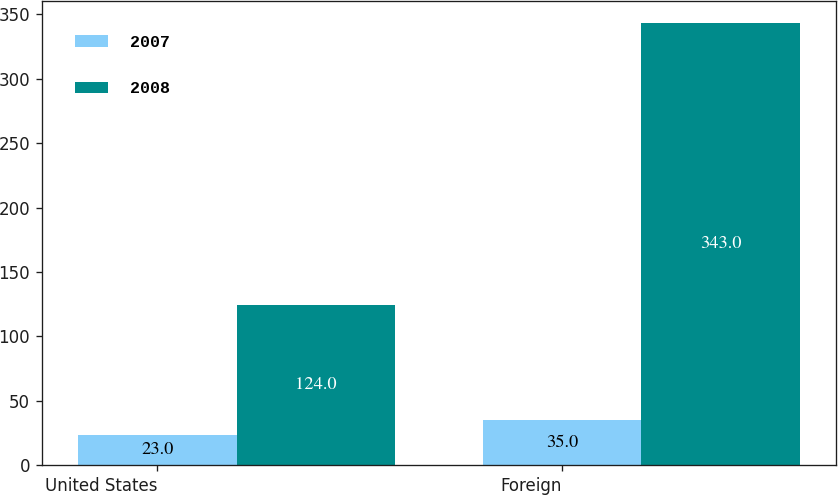Convert chart to OTSL. <chart><loc_0><loc_0><loc_500><loc_500><stacked_bar_chart><ecel><fcel>United States<fcel>Foreign<nl><fcel>2007<fcel>23<fcel>35<nl><fcel>2008<fcel>124<fcel>343<nl></chart> 